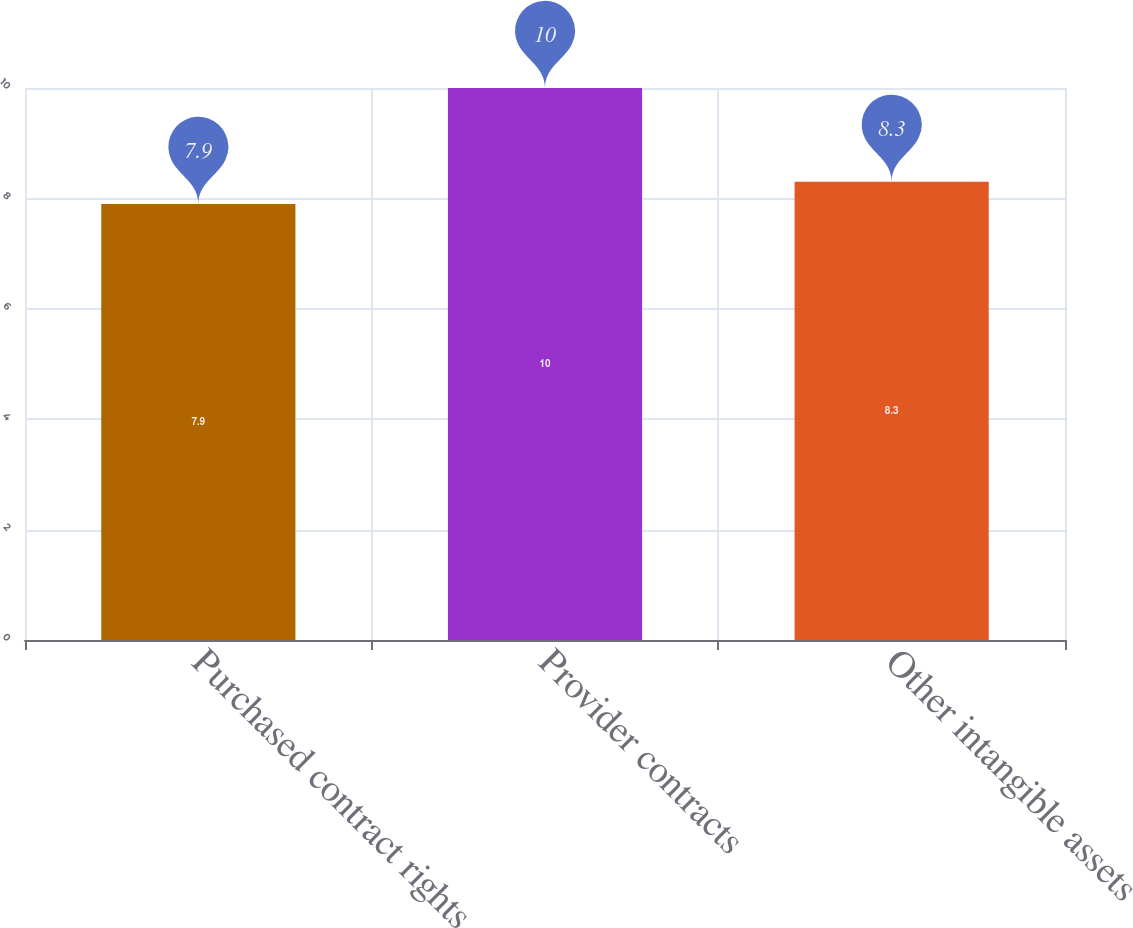Convert chart to OTSL. <chart><loc_0><loc_0><loc_500><loc_500><bar_chart><fcel>Purchased contract rights<fcel>Provider contracts<fcel>Other intangible assets<nl><fcel>7.9<fcel>10<fcel>8.3<nl></chart> 